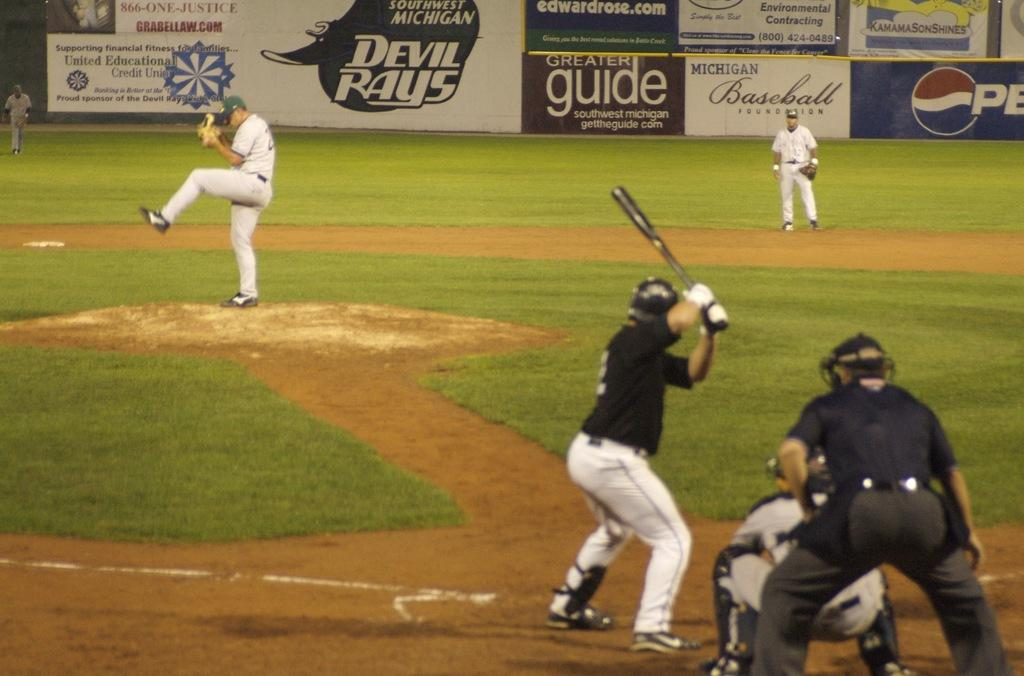Provide a one-sentence caption for the provided image. The Michigan Devil Rays are playing baseball against an opposing team with a batter currently at the plate. 